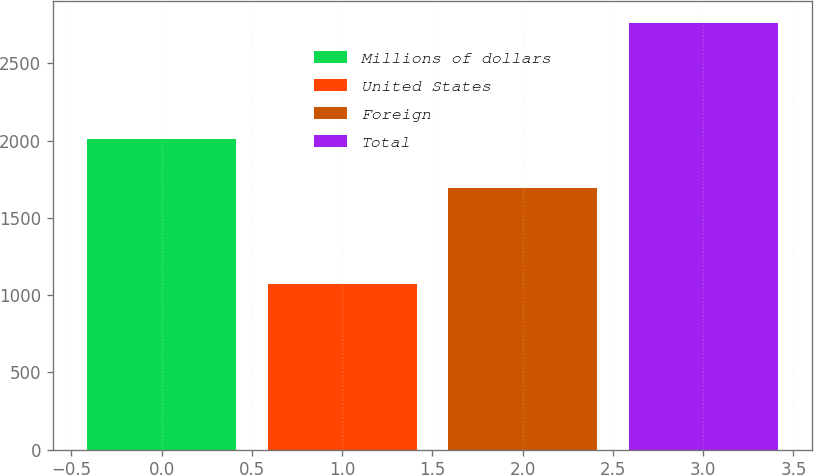Convert chart. <chart><loc_0><loc_0><loc_500><loc_500><bar_chart><fcel>Millions of dollars<fcel>United States<fcel>Foreign<fcel>Total<nl><fcel>2013<fcel>1070<fcel>1694<fcel>2764<nl></chart> 